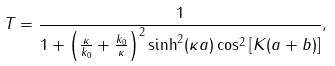Convert formula to latex. <formula><loc_0><loc_0><loc_500><loc_500>T = \frac { 1 } { 1 + \left ( \frac { \kappa } { k _ { 0 } } + \frac { k _ { 0 } } { \kappa } \right ) ^ { 2 } \sinh ^ { 2 } ( \kappa a ) \cos ^ { 2 } \left [ K ( a + b ) \right ] } ,</formula> 